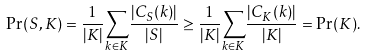Convert formula to latex. <formula><loc_0><loc_0><loc_500><loc_500>\Pr ( S , K ) = \frac { 1 } { | K | } \underset { k \in K } { \sum } \frac { | C _ { S } ( k ) | } { | S | } \geq \frac { 1 } { | K | } \underset { k \in K } { \sum } \frac { | C _ { K } ( k ) | } { | K | } = \Pr ( K ) .</formula> 